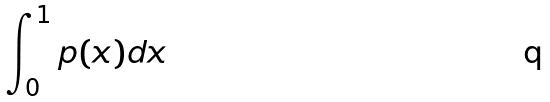Convert formula to latex. <formula><loc_0><loc_0><loc_500><loc_500>\int _ { 0 } ^ { 1 } p ( x ) d x</formula> 